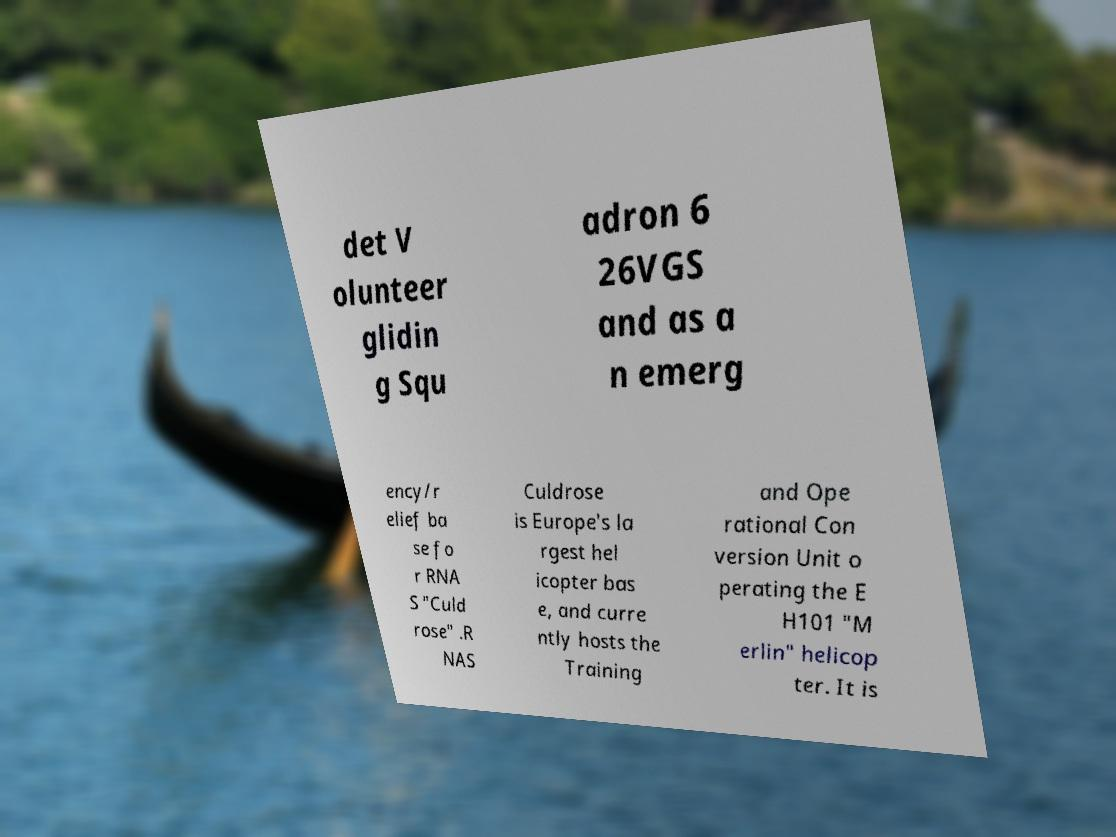Can you accurately transcribe the text from the provided image for me? det V olunteer glidin g Squ adron 6 26VGS and as a n emerg ency/r elief ba se fo r RNA S "Culd rose" .R NAS Culdrose is Europe's la rgest hel icopter bas e, and curre ntly hosts the Training and Ope rational Con version Unit o perating the E H101 "M erlin" helicop ter. It is 